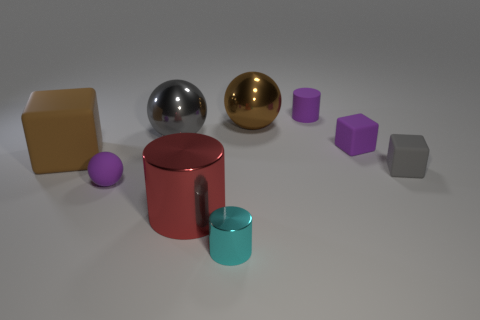Subtract all brown rubber blocks. How many blocks are left? 2 Subtract all spheres. How many objects are left? 6 Subtract 2 cylinders. How many cylinders are left? 1 Subtract all blue cylinders. Subtract all yellow cubes. How many cylinders are left? 3 Subtract all purple blocks. How many purple cylinders are left? 1 Subtract all brown blocks. How many blocks are left? 2 Subtract all matte blocks. Subtract all matte balls. How many objects are left? 5 Add 3 big gray metallic things. How many big gray metallic things are left? 4 Add 9 big yellow rubber cubes. How many big yellow rubber cubes exist? 9 Subtract 1 cyan cylinders. How many objects are left? 8 